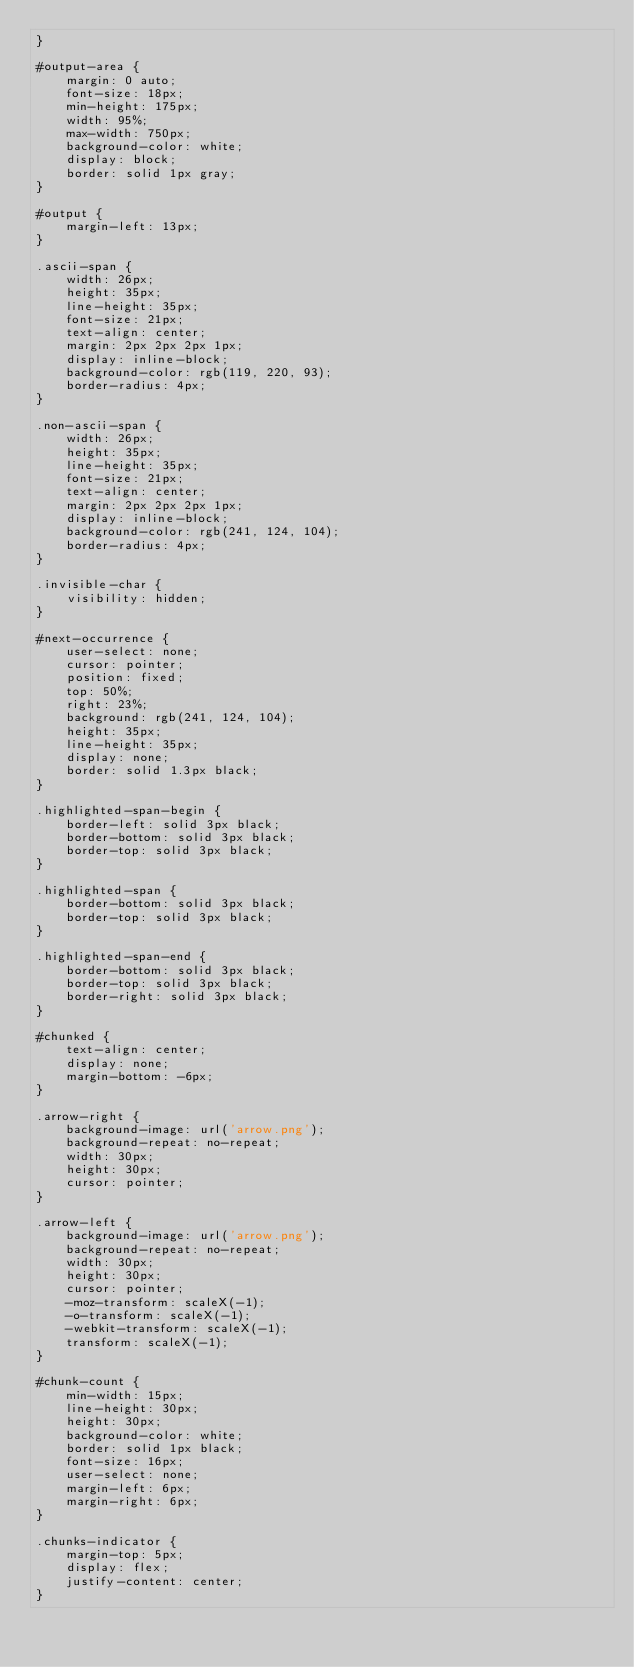<code> <loc_0><loc_0><loc_500><loc_500><_CSS_>}

#output-area {
    margin: 0 auto;
    font-size: 18px;
    min-height: 175px;
    width: 95%;
    max-width: 750px;
    background-color: white;
    display: block;
    border: solid 1px gray;
}

#output {
    margin-left: 13px;
}

.ascii-span {
    width: 26px;
    height: 35px;
    line-height: 35px;
    font-size: 21px;
    text-align: center;
    margin: 2px 2px 2px 1px;
    display: inline-block;
    background-color: rgb(119, 220, 93);
    border-radius: 4px;
}

.non-ascii-span {
    width: 26px;
    height: 35px;
    line-height: 35px;
    font-size: 21px;
    text-align: center;
    margin: 2px 2px 2px 1px;
    display: inline-block;
    background-color: rgb(241, 124, 104);
    border-radius: 4px;
}

.invisible-char {
    visibility: hidden;
}

#next-occurrence {
    user-select: none;
    cursor: pointer;
    position: fixed;
    top: 50%;
    right: 23%;
    background: rgb(241, 124, 104);
    height: 35px;
    line-height: 35px;
    display: none;
    border: solid 1.3px black;
}

.highlighted-span-begin {
    border-left: solid 3px black;
    border-bottom: solid 3px black;
    border-top: solid 3px black;
}

.highlighted-span {
    border-bottom: solid 3px black;
    border-top: solid 3px black;
}

.highlighted-span-end {
    border-bottom: solid 3px black;
    border-top: solid 3px black;
    border-right: solid 3px black;
}

#chunked {
    text-align: center;
    display: none;
    margin-bottom: -6px;
}

.arrow-right {
    background-image: url('arrow.png');
    background-repeat: no-repeat;
    width: 30px;
    height: 30px;
    cursor: pointer;
}

.arrow-left {
    background-image: url('arrow.png');
    background-repeat: no-repeat;
    width: 30px;
    height: 30px;
    cursor: pointer;
    -moz-transform: scaleX(-1);
    -o-transform: scaleX(-1);
    -webkit-transform: scaleX(-1);
    transform: scaleX(-1);
}

#chunk-count {
    min-width: 15px;
    line-height: 30px;
    height: 30px;
    background-color: white;
    border: solid 1px black;
    font-size: 16px;
    user-select: none;
    margin-left: 6px;
    margin-right: 6px;
}

.chunks-indicator {
    margin-top: 5px;
    display: flex;
    justify-content: center;
}</code> 